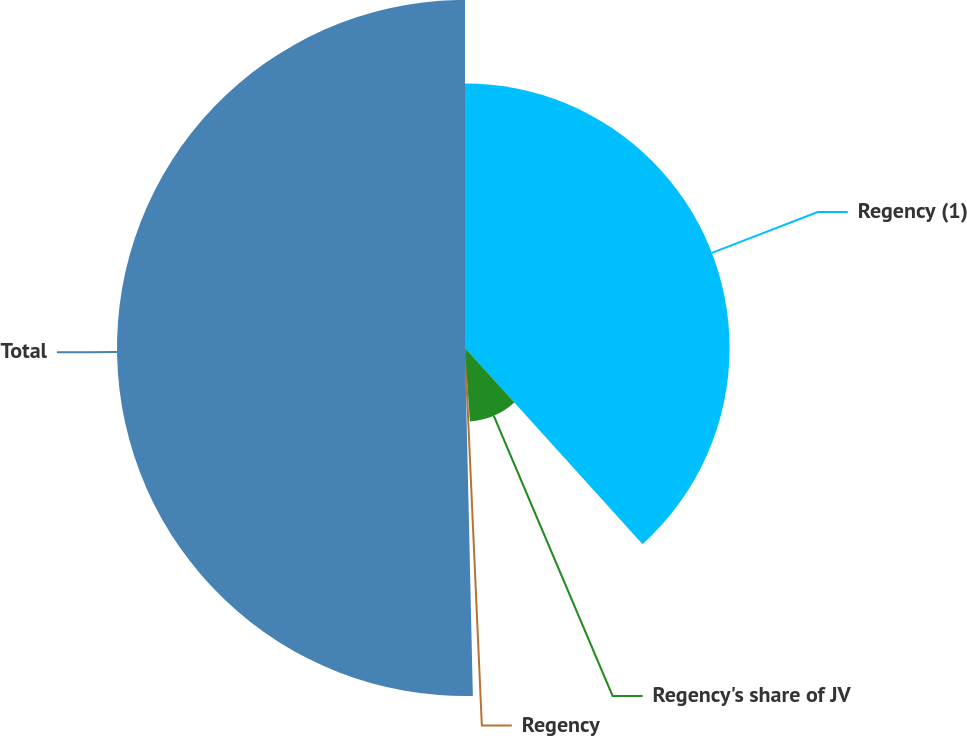<chart> <loc_0><loc_0><loc_500><loc_500><pie_chart><fcel>Regency (1)<fcel>Regency's share of JV<fcel>Regency<fcel>Total<nl><fcel>38.29%<fcel>10.65%<fcel>0.7%<fcel>50.36%<nl></chart> 